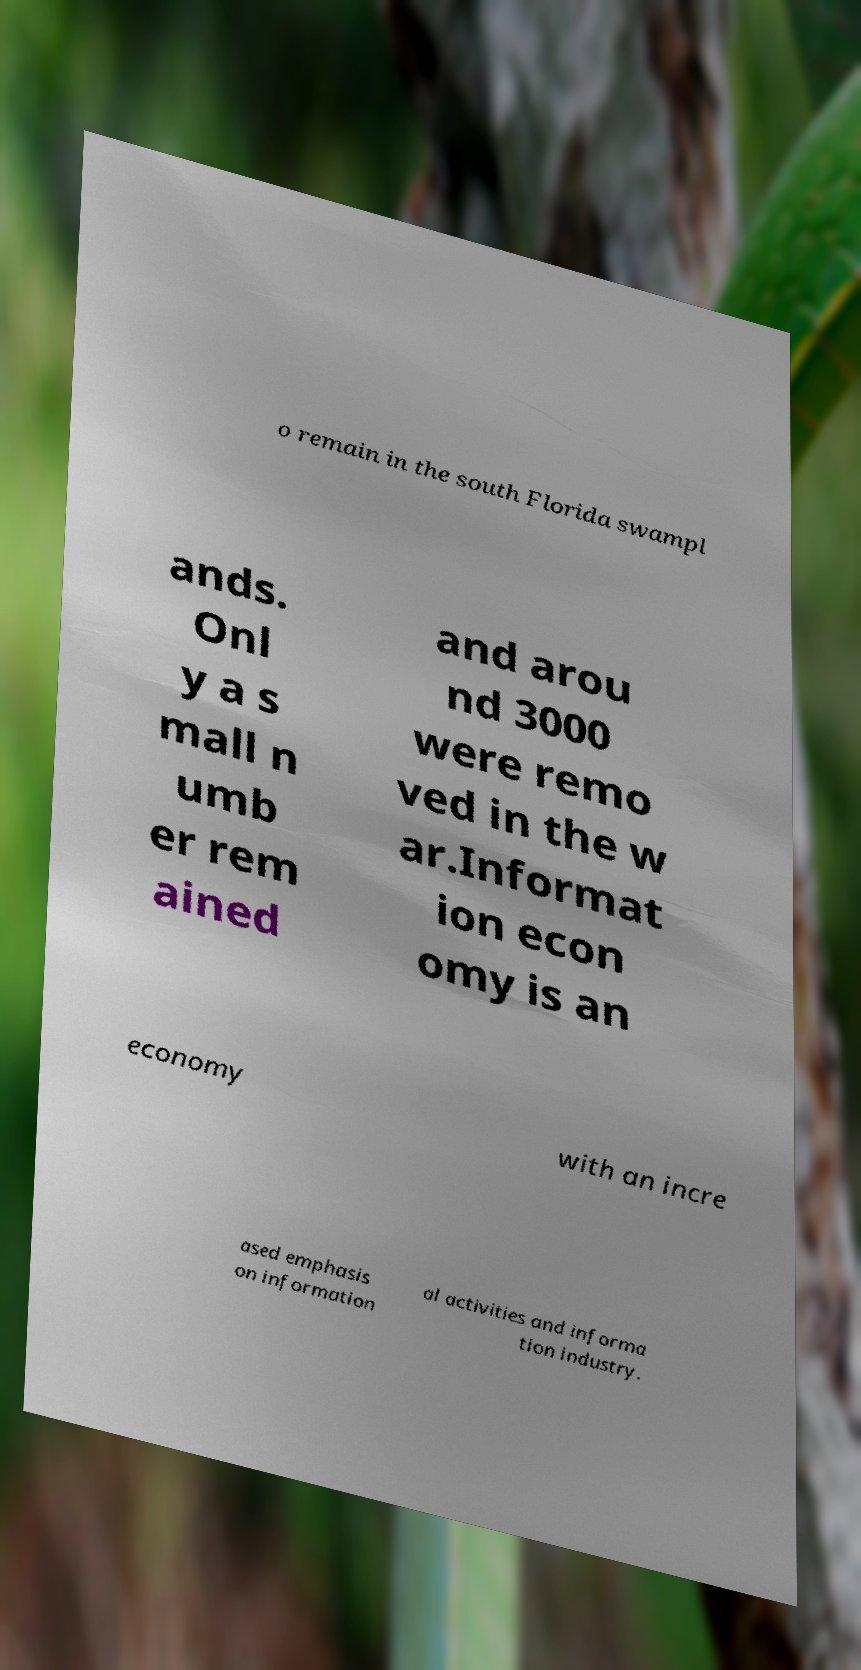For documentation purposes, I need the text within this image transcribed. Could you provide that? o remain in the south Florida swampl ands. Onl y a s mall n umb er rem ained and arou nd 3000 were remo ved in the w ar.Informat ion econ omy is an economy with an incre ased emphasis on information al activities and informa tion industry. 